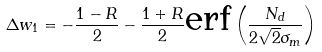<formula> <loc_0><loc_0><loc_500><loc_500>\Delta w _ { 1 } = - \frac { 1 - R } { 2 } - \frac { 1 + R } { 2 } \text {erf} \left ( \frac { N _ { d } } { 2 \sqrt { 2 } \sigma _ { m } } \right )</formula> 